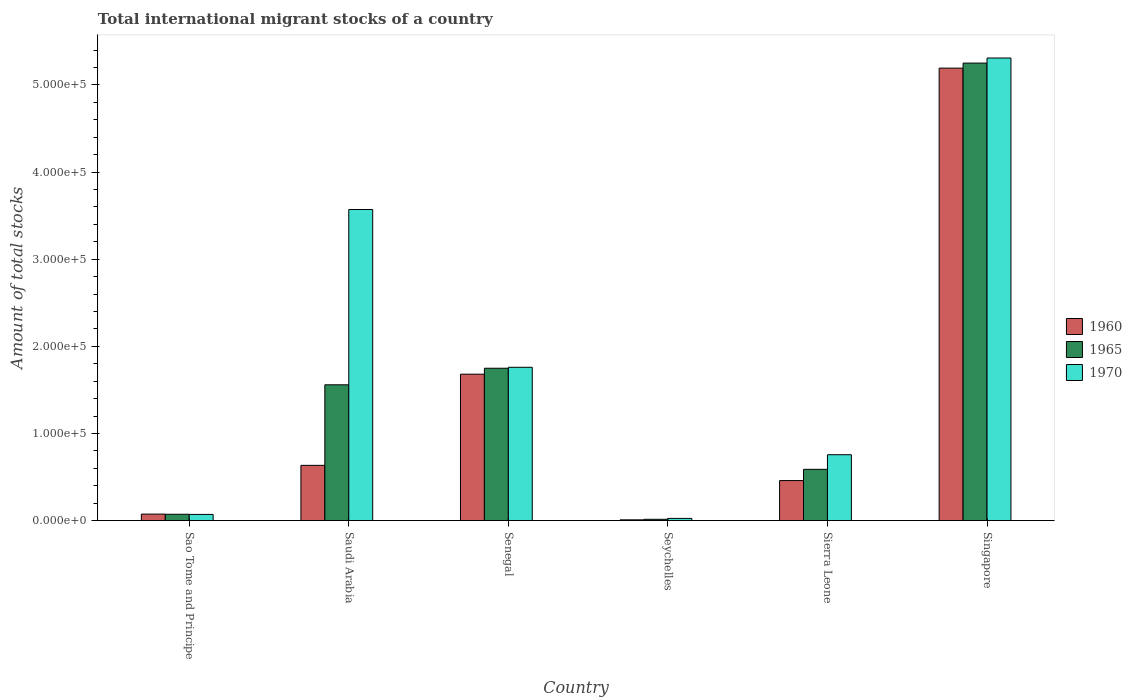How many groups of bars are there?
Your answer should be very brief. 6. Are the number of bars per tick equal to the number of legend labels?
Provide a succinct answer. Yes. What is the label of the 5th group of bars from the left?
Give a very brief answer. Sierra Leone. What is the amount of total stocks in in 1960 in Sierra Leone?
Offer a very short reply. 4.59e+04. Across all countries, what is the maximum amount of total stocks in in 1960?
Your response must be concise. 5.19e+05. Across all countries, what is the minimum amount of total stocks in in 1970?
Offer a terse response. 2506. In which country was the amount of total stocks in in 1965 maximum?
Ensure brevity in your answer.  Singapore. In which country was the amount of total stocks in in 1960 minimum?
Offer a terse response. Seychelles. What is the total amount of total stocks in in 1960 in the graph?
Offer a very short reply. 8.05e+05. What is the difference between the amount of total stocks in in 1965 in Senegal and that in Singapore?
Keep it short and to the point. -3.50e+05. What is the difference between the amount of total stocks in in 1970 in Sao Tome and Principe and the amount of total stocks in in 1960 in Senegal?
Provide a succinct answer. -1.61e+05. What is the average amount of total stocks in in 1960 per country?
Your answer should be very brief. 1.34e+05. What is the difference between the amount of total stocks in of/in 1965 and amount of total stocks in of/in 1970 in Sierra Leone?
Your answer should be very brief. -1.68e+04. In how many countries, is the amount of total stocks in in 1965 greater than 300000?
Make the answer very short. 1. What is the ratio of the amount of total stocks in in 1970 in Saudi Arabia to that in Senegal?
Your answer should be compact. 2.03. Is the amount of total stocks in in 1960 in Sao Tome and Principe less than that in Singapore?
Make the answer very short. Yes. Is the difference between the amount of total stocks in in 1965 in Senegal and Seychelles greater than the difference between the amount of total stocks in in 1970 in Senegal and Seychelles?
Provide a short and direct response. No. What is the difference between the highest and the second highest amount of total stocks in in 1965?
Your response must be concise. 1.90e+04. What is the difference between the highest and the lowest amount of total stocks in in 1960?
Provide a short and direct response. 5.18e+05. In how many countries, is the amount of total stocks in in 1960 greater than the average amount of total stocks in in 1960 taken over all countries?
Make the answer very short. 2. What does the 2nd bar from the left in Seychelles represents?
Give a very brief answer. 1965. What does the 1st bar from the right in Seychelles represents?
Offer a terse response. 1970. Is it the case that in every country, the sum of the amount of total stocks in in 1965 and amount of total stocks in in 1960 is greater than the amount of total stocks in in 1970?
Your answer should be compact. No. Are the values on the major ticks of Y-axis written in scientific E-notation?
Provide a short and direct response. Yes. Does the graph contain grids?
Your answer should be compact. No. What is the title of the graph?
Provide a short and direct response. Total international migrant stocks of a country. Does "1960" appear as one of the legend labels in the graph?
Provide a succinct answer. Yes. What is the label or title of the X-axis?
Your answer should be compact. Country. What is the label or title of the Y-axis?
Ensure brevity in your answer.  Amount of total stocks. What is the Amount of total stocks in 1960 in Sao Tome and Principe?
Provide a short and direct response. 7436. What is the Amount of total stocks in 1965 in Sao Tome and Principe?
Offer a very short reply. 7253. What is the Amount of total stocks of 1970 in Sao Tome and Principe?
Make the answer very short. 7074. What is the Amount of total stocks in 1960 in Saudi Arabia?
Your answer should be compact. 6.34e+04. What is the Amount of total stocks of 1965 in Saudi Arabia?
Offer a terse response. 1.56e+05. What is the Amount of total stocks of 1970 in Saudi Arabia?
Keep it short and to the point. 3.57e+05. What is the Amount of total stocks in 1960 in Senegal?
Provide a short and direct response. 1.68e+05. What is the Amount of total stocks in 1965 in Senegal?
Your answer should be compact. 1.75e+05. What is the Amount of total stocks in 1970 in Senegal?
Keep it short and to the point. 1.76e+05. What is the Amount of total stocks in 1960 in Seychelles?
Offer a terse response. 845. What is the Amount of total stocks in 1965 in Seychelles?
Provide a short and direct response. 1455. What is the Amount of total stocks of 1970 in Seychelles?
Offer a very short reply. 2506. What is the Amount of total stocks of 1960 in Sierra Leone?
Give a very brief answer. 4.59e+04. What is the Amount of total stocks in 1965 in Sierra Leone?
Your answer should be compact. 5.88e+04. What is the Amount of total stocks of 1970 in Sierra Leone?
Your answer should be very brief. 7.56e+04. What is the Amount of total stocks in 1960 in Singapore?
Ensure brevity in your answer.  5.19e+05. What is the Amount of total stocks in 1965 in Singapore?
Keep it short and to the point. 5.25e+05. What is the Amount of total stocks in 1970 in Singapore?
Give a very brief answer. 5.31e+05. Across all countries, what is the maximum Amount of total stocks in 1960?
Keep it short and to the point. 5.19e+05. Across all countries, what is the maximum Amount of total stocks in 1965?
Offer a very short reply. 5.25e+05. Across all countries, what is the maximum Amount of total stocks of 1970?
Make the answer very short. 5.31e+05. Across all countries, what is the minimum Amount of total stocks of 1960?
Offer a terse response. 845. Across all countries, what is the minimum Amount of total stocks in 1965?
Your answer should be very brief. 1455. Across all countries, what is the minimum Amount of total stocks of 1970?
Ensure brevity in your answer.  2506. What is the total Amount of total stocks of 1960 in the graph?
Offer a terse response. 8.05e+05. What is the total Amount of total stocks in 1965 in the graph?
Offer a terse response. 9.23e+05. What is the total Amount of total stocks in 1970 in the graph?
Your answer should be very brief. 1.15e+06. What is the difference between the Amount of total stocks in 1960 in Sao Tome and Principe and that in Saudi Arabia?
Your answer should be very brief. -5.60e+04. What is the difference between the Amount of total stocks of 1965 in Sao Tome and Principe and that in Saudi Arabia?
Your answer should be compact. -1.49e+05. What is the difference between the Amount of total stocks of 1970 in Sao Tome and Principe and that in Saudi Arabia?
Keep it short and to the point. -3.50e+05. What is the difference between the Amount of total stocks in 1960 in Sao Tome and Principe and that in Senegal?
Your answer should be compact. -1.61e+05. What is the difference between the Amount of total stocks of 1965 in Sao Tome and Principe and that in Senegal?
Your answer should be compact. -1.68e+05. What is the difference between the Amount of total stocks of 1970 in Sao Tome and Principe and that in Senegal?
Ensure brevity in your answer.  -1.69e+05. What is the difference between the Amount of total stocks of 1960 in Sao Tome and Principe and that in Seychelles?
Keep it short and to the point. 6591. What is the difference between the Amount of total stocks of 1965 in Sao Tome and Principe and that in Seychelles?
Ensure brevity in your answer.  5798. What is the difference between the Amount of total stocks of 1970 in Sao Tome and Principe and that in Seychelles?
Offer a terse response. 4568. What is the difference between the Amount of total stocks in 1960 in Sao Tome and Principe and that in Sierra Leone?
Provide a short and direct response. -3.85e+04. What is the difference between the Amount of total stocks of 1965 in Sao Tome and Principe and that in Sierra Leone?
Provide a succinct answer. -5.16e+04. What is the difference between the Amount of total stocks in 1970 in Sao Tome and Principe and that in Sierra Leone?
Your answer should be compact. -6.85e+04. What is the difference between the Amount of total stocks in 1960 in Sao Tome and Principe and that in Singapore?
Your response must be concise. -5.12e+05. What is the difference between the Amount of total stocks of 1965 in Sao Tome and Principe and that in Singapore?
Your answer should be compact. -5.18e+05. What is the difference between the Amount of total stocks in 1970 in Sao Tome and Principe and that in Singapore?
Ensure brevity in your answer.  -5.24e+05. What is the difference between the Amount of total stocks of 1960 in Saudi Arabia and that in Senegal?
Give a very brief answer. -1.05e+05. What is the difference between the Amount of total stocks in 1965 in Saudi Arabia and that in Senegal?
Provide a short and direct response. -1.90e+04. What is the difference between the Amount of total stocks of 1970 in Saudi Arabia and that in Senegal?
Offer a very short reply. 1.81e+05. What is the difference between the Amount of total stocks in 1960 in Saudi Arabia and that in Seychelles?
Make the answer very short. 6.25e+04. What is the difference between the Amount of total stocks in 1965 in Saudi Arabia and that in Seychelles?
Your response must be concise. 1.54e+05. What is the difference between the Amount of total stocks in 1970 in Saudi Arabia and that in Seychelles?
Make the answer very short. 3.54e+05. What is the difference between the Amount of total stocks in 1960 in Saudi Arabia and that in Sierra Leone?
Provide a succinct answer. 1.75e+04. What is the difference between the Amount of total stocks in 1965 in Saudi Arabia and that in Sierra Leone?
Your answer should be compact. 9.70e+04. What is the difference between the Amount of total stocks in 1970 in Saudi Arabia and that in Sierra Leone?
Your answer should be compact. 2.81e+05. What is the difference between the Amount of total stocks in 1960 in Saudi Arabia and that in Singapore?
Give a very brief answer. -4.56e+05. What is the difference between the Amount of total stocks of 1965 in Saudi Arabia and that in Singapore?
Your response must be concise. -3.69e+05. What is the difference between the Amount of total stocks of 1970 in Saudi Arabia and that in Singapore?
Your answer should be compact. -1.74e+05. What is the difference between the Amount of total stocks in 1960 in Senegal and that in Seychelles?
Your answer should be compact. 1.67e+05. What is the difference between the Amount of total stocks in 1965 in Senegal and that in Seychelles?
Make the answer very short. 1.73e+05. What is the difference between the Amount of total stocks in 1970 in Senegal and that in Seychelles?
Your answer should be compact. 1.73e+05. What is the difference between the Amount of total stocks in 1960 in Senegal and that in Sierra Leone?
Your response must be concise. 1.22e+05. What is the difference between the Amount of total stocks of 1965 in Senegal and that in Sierra Leone?
Your response must be concise. 1.16e+05. What is the difference between the Amount of total stocks of 1970 in Senegal and that in Sierra Leone?
Keep it short and to the point. 1.00e+05. What is the difference between the Amount of total stocks in 1960 in Senegal and that in Singapore?
Give a very brief answer. -3.51e+05. What is the difference between the Amount of total stocks in 1965 in Senegal and that in Singapore?
Your response must be concise. -3.50e+05. What is the difference between the Amount of total stocks in 1970 in Senegal and that in Singapore?
Make the answer very short. -3.55e+05. What is the difference between the Amount of total stocks of 1960 in Seychelles and that in Sierra Leone?
Offer a very short reply. -4.51e+04. What is the difference between the Amount of total stocks in 1965 in Seychelles and that in Sierra Leone?
Offer a terse response. -5.74e+04. What is the difference between the Amount of total stocks in 1970 in Seychelles and that in Sierra Leone?
Keep it short and to the point. -7.31e+04. What is the difference between the Amount of total stocks of 1960 in Seychelles and that in Singapore?
Offer a very short reply. -5.18e+05. What is the difference between the Amount of total stocks of 1965 in Seychelles and that in Singapore?
Offer a very short reply. -5.24e+05. What is the difference between the Amount of total stocks in 1970 in Seychelles and that in Singapore?
Your response must be concise. -5.28e+05. What is the difference between the Amount of total stocks of 1960 in Sierra Leone and that in Singapore?
Keep it short and to the point. -4.73e+05. What is the difference between the Amount of total stocks in 1965 in Sierra Leone and that in Singapore?
Offer a very short reply. -4.66e+05. What is the difference between the Amount of total stocks of 1970 in Sierra Leone and that in Singapore?
Make the answer very short. -4.55e+05. What is the difference between the Amount of total stocks of 1960 in Sao Tome and Principe and the Amount of total stocks of 1965 in Saudi Arabia?
Make the answer very short. -1.48e+05. What is the difference between the Amount of total stocks in 1960 in Sao Tome and Principe and the Amount of total stocks in 1970 in Saudi Arabia?
Ensure brevity in your answer.  -3.50e+05. What is the difference between the Amount of total stocks of 1965 in Sao Tome and Principe and the Amount of total stocks of 1970 in Saudi Arabia?
Give a very brief answer. -3.50e+05. What is the difference between the Amount of total stocks of 1960 in Sao Tome and Principe and the Amount of total stocks of 1965 in Senegal?
Your answer should be very brief. -1.67e+05. What is the difference between the Amount of total stocks in 1960 in Sao Tome and Principe and the Amount of total stocks in 1970 in Senegal?
Make the answer very short. -1.68e+05. What is the difference between the Amount of total stocks of 1965 in Sao Tome and Principe and the Amount of total stocks of 1970 in Senegal?
Make the answer very short. -1.69e+05. What is the difference between the Amount of total stocks of 1960 in Sao Tome and Principe and the Amount of total stocks of 1965 in Seychelles?
Give a very brief answer. 5981. What is the difference between the Amount of total stocks of 1960 in Sao Tome and Principe and the Amount of total stocks of 1970 in Seychelles?
Provide a short and direct response. 4930. What is the difference between the Amount of total stocks of 1965 in Sao Tome and Principe and the Amount of total stocks of 1970 in Seychelles?
Offer a terse response. 4747. What is the difference between the Amount of total stocks of 1960 in Sao Tome and Principe and the Amount of total stocks of 1965 in Sierra Leone?
Provide a succinct answer. -5.14e+04. What is the difference between the Amount of total stocks of 1960 in Sao Tome and Principe and the Amount of total stocks of 1970 in Sierra Leone?
Offer a very short reply. -6.81e+04. What is the difference between the Amount of total stocks in 1965 in Sao Tome and Principe and the Amount of total stocks in 1970 in Sierra Leone?
Your answer should be compact. -6.83e+04. What is the difference between the Amount of total stocks of 1960 in Sao Tome and Principe and the Amount of total stocks of 1965 in Singapore?
Your response must be concise. -5.18e+05. What is the difference between the Amount of total stocks of 1960 in Sao Tome and Principe and the Amount of total stocks of 1970 in Singapore?
Your answer should be compact. -5.23e+05. What is the difference between the Amount of total stocks of 1965 in Sao Tome and Principe and the Amount of total stocks of 1970 in Singapore?
Your answer should be compact. -5.24e+05. What is the difference between the Amount of total stocks of 1960 in Saudi Arabia and the Amount of total stocks of 1965 in Senegal?
Your answer should be compact. -1.11e+05. What is the difference between the Amount of total stocks of 1960 in Saudi Arabia and the Amount of total stocks of 1970 in Senegal?
Give a very brief answer. -1.13e+05. What is the difference between the Amount of total stocks in 1965 in Saudi Arabia and the Amount of total stocks in 1970 in Senegal?
Make the answer very short. -2.01e+04. What is the difference between the Amount of total stocks of 1960 in Saudi Arabia and the Amount of total stocks of 1965 in Seychelles?
Ensure brevity in your answer.  6.19e+04. What is the difference between the Amount of total stocks of 1960 in Saudi Arabia and the Amount of total stocks of 1970 in Seychelles?
Ensure brevity in your answer.  6.09e+04. What is the difference between the Amount of total stocks in 1965 in Saudi Arabia and the Amount of total stocks in 1970 in Seychelles?
Give a very brief answer. 1.53e+05. What is the difference between the Amount of total stocks in 1960 in Saudi Arabia and the Amount of total stocks in 1965 in Sierra Leone?
Ensure brevity in your answer.  4580. What is the difference between the Amount of total stocks in 1960 in Saudi Arabia and the Amount of total stocks in 1970 in Sierra Leone?
Ensure brevity in your answer.  -1.22e+04. What is the difference between the Amount of total stocks in 1965 in Saudi Arabia and the Amount of total stocks in 1970 in Sierra Leone?
Provide a succinct answer. 8.02e+04. What is the difference between the Amount of total stocks in 1960 in Saudi Arabia and the Amount of total stocks in 1965 in Singapore?
Your answer should be very brief. -4.62e+05. What is the difference between the Amount of total stocks in 1960 in Saudi Arabia and the Amount of total stocks in 1970 in Singapore?
Give a very brief answer. -4.67e+05. What is the difference between the Amount of total stocks of 1965 in Saudi Arabia and the Amount of total stocks of 1970 in Singapore?
Your answer should be compact. -3.75e+05. What is the difference between the Amount of total stocks of 1960 in Senegal and the Amount of total stocks of 1965 in Seychelles?
Give a very brief answer. 1.67e+05. What is the difference between the Amount of total stocks in 1960 in Senegal and the Amount of total stocks in 1970 in Seychelles?
Provide a succinct answer. 1.66e+05. What is the difference between the Amount of total stocks in 1965 in Senegal and the Amount of total stocks in 1970 in Seychelles?
Ensure brevity in your answer.  1.72e+05. What is the difference between the Amount of total stocks in 1960 in Senegal and the Amount of total stocks in 1965 in Sierra Leone?
Your response must be concise. 1.09e+05. What is the difference between the Amount of total stocks of 1960 in Senegal and the Amount of total stocks of 1970 in Sierra Leone?
Make the answer very short. 9.24e+04. What is the difference between the Amount of total stocks of 1965 in Senegal and the Amount of total stocks of 1970 in Sierra Leone?
Ensure brevity in your answer.  9.92e+04. What is the difference between the Amount of total stocks of 1960 in Senegal and the Amount of total stocks of 1965 in Singapore?
Keep it short and to the point. -3.57e+05. What is the difference between the Amount of total stocks of 1960 in Senegal and the Amount of total stocks of 1970 in Singapore?
Your answer should be compact. -3.63e+05. What is the difference between the Amount of total stocks in 1965 in Senegal and the Amount of total stocks in 1970 in Singapore?
Your response must be concise. -3.56e+05. What is the difference between the Amount of total stocks in 1960 in Seychelles and the Amount of total stocks in 1965 in Sierra Leone?
Your response must be concise. -5.80e+04. What is the difference between the Amount of total stocks of 1960 in Seychelles and the Amount of total stocks of 1970 in Sierra Leone?
Give a very brief answer. -7.47e+04. What is the difference between the Amount of total stocks of 1965 in Seychelles and the Amount of total stocks of 1970 in Sierra Leone?
Your response must be concise. -7.41e+04. What is the difference between the Amount of total stocks of 1960 in Seychelles and the Amount of total stocks of 1965 in Singapore?
Your answer should be compact. -5.24e+05. What is the difference between the Amount of total stocks of 1960 in Seychelles and the Amount of total stocks of 1970 in Singapore?
Your answer should be compact. -5.30e+05. What is the difference between the Amount of total stocks in 1965 in Seychelles and the Amount of total stocks in 1970 in Singapore?
Your answer should be very brief. -5.29e+05. What is the difference between the Amount of total stocks in 1960 in Sierra Leone and the Amount of total stocks in 1965 in Singapore?
Your answer should be very brief. -4.79e+05. What is the difference between the Amount of total stocks in 1960 in Sierra Leone and the Amount of total stocks in 1970 in Singapore?
Offer a very short reply. -4.85e+05. What is the difference between the Amount of total stocks of 1965 in Sierra Leone and the Amount of total stocks of 1970 in Singapore?
Ensure brevity in your answer.  -4.72e+05. What is the average Amount of total stocks of 1960 per country?
Your response must be concise. 1.34e+05. What is the average Amount of total stocks of 1965 per country?
Your answer should be very brief. 1.54e+05. What is the average Amount of total stocks of 1970 per country?
Your answer should be compact. 1.91e+05. What is the difference between the Amount of total stocks in 1960 and Amount of total stocks in 1965 in Sao Tome and Principe?
Your response must be concise. 183. What is the difference between the Amount of total stocks in 1960 and Amount of total stocks in 1970 in Sao Tome and Principe?
Your answer should be compact. 362. What is the difference between the Amount of total stocks of 1965 and Amount of total stocks of 1970 in Sao Tome and Principe?
Offer a terse response. 179. What is the difference between the Amount of total stocks of 1960 and Amount of total stocks of 1965 in Saudi Arabia?
Make the answer very short. -9.24e+04. What is the difference between the Amount of total stocks of 1960 and Amount of total stocks of 1970 in Saudi Arabia?
Give a very brief answer. -2.94e+05. What is the difference between the Amount of total stocks of 1965 and Amount of total stocks of 1970 in Saudi Arabia?
Provide a short and direct response. -2.01e+05. What is the difference between the Amount of total stocks of 1960 and Amount of total stocks of 1965 in Senegal?
Your answer should be compact. -6804. What is the difference between the Amount of total stocks in 1960 and Amount of total stocks in 1970 in Senegal?
Provide a short and direct response. -7897. What is the difference between the Amount of total stocks in 1965 and Amount of total stocks in 1970 in Senegal?
Your answer should be compact. -1093. What is the difference between the Amount of total stocks in 1960 and Amount of total stocks in 1965 in Seychelles?
Give a very brief answer. -610. What is the difference between the Amount of total stocks in 1960 and Amount of total stocks in 1970 in Seychelles?
Your response must be concise. -1661. What is the difference between the Amount of total stocks in 1965 and Amount of total stocks in 1970 in Seychelles?
Your response must be concise. -1051. What is the difference between the Amount of total stocks of 1960 and Amount of total stocks of 1965 in Sierra Leone?
Your answer should be compact. -1.29e+04. What is the difference between the Amount of total stocks of 1960 and Amount of total stocks of 1970 in Sierra Leone?
Provide a succinct answer. -2.97e+04. What is the difference between the Amount of total stocks in 1965 and Amount of total stocks in 1970 in Sierra Leone?
Your answer should be compact. -1.68e+04. What is the difference between the Amount of total stocks of 1960 and Amount of total stocks of 1965 in Singapore?
Your answer should be compact. -5801. What is the difference between the Amount of total stocks of 1960 and Amount of total stocks of 1970 in Singapore?
Keep it short and to the point. -1.16e+04. What is the difference between the Amount of total stocks in 1965 and Amount of total stocks in 1970 in Singapore?
Make the answer very short. -5826. What is the ratio of the Amount of total stocks in 1960 in Sao Tome and Principe to that in Saudi Arabia?
Make the answer very short. 0.12. What is the ratio of the Amount of total stocks of 1965 in Sao Tome and Principe to that in Saudi Arabia?
Provide a short and direct response. 0.05. What is the ratio of the Amount of total stocks of 1970 in Sao Tome and Principe to that in Saudi Arabia?
Provide a succinct answer. 0.02. What is the ratio of the Amount of total stocks in 1960 in Sao Tome and Principe to that in Senegal?
Your response must be concise. 0.04. What is the ratio of the Amount of total stocks of 1965 in Sao Tome and Principe to that in Senegal?
Give a very brief answer. 0.04. What is the ratio of the Amount of total stocks in 1970 in Sao Tome and Principe to that in Senegal?
Offer a terse response. 0.04. What is the ratio of the Amount of total stocks in 1960 in Sao Tome and Principe to that in Seychelles?
Your answer should be very brief. 8.8. What is the ratio of the Amount of total stocks of 1965 in Sao Tome and Principe to that in Seychelles?
Your response must be concise. 4.98. What is the ratio of the Amount of total stocks in 1970 in Sao Tome and Principe to that in Seychelles?
Offer a very short reply. 2.82. What is the ratio of the Amount of total stocks of 1960 in Sao Tome and Principe to that in Sierra Leone?
Make the answer very short. 0.16. What is the ratio of the Amount of total stocks in 1965 in Sao Tome and Principe to that in Sierra Leone?
Offer a very short reply. 0.12. What is the ratio of the Amount of total stocks in 1970 in Sao Tome and Principe to that in Sierra Leone?
Keep it short and to the point. 0.09. What is the ratio of the Amount of total stocks in 1960 in Sao Tome and Principe to that in Singapore?
Offer a very short reply. 0.01. What is the ratio of the Amount of total stocks in 1965 in Sao Tome and Principe to that in Singapore?
Your answer should be very brief. 0.01. What is the ratio of the Amount of total stocks in 1970 in Sao Tome and Principe to that in Singapore?
Give a very brief answer. 0.01. What is the ratio of the Amount of total stocks of 1960 in Saudi Arabia to that in Senegal?
Offer a very short reply. 0.38. What is the ratio of the Amount of total stocks in 1965 in Saudi Arabia to that in Senegal?
Offer a terse response. 0.89. What is the ratio of the Amount of total stocks in 1970 in Saudi Arabia to that in Senegal?
Give a very brief answer. 2.03. What is the ratio of the Amount of total stocks of 1960 in Saudi Arabia to that in Seychelles?
Give a very brief answer. 75.02. What is the ratio of the Amount of total stocks of 1965 in Saudi Arabia to that in Seychelles?
Make the answer very short. 107.09. What is the ratio of the Amount of total stocks of 1970 in Saudi Arabia to that in Seychelles?
Make the answer very short. 142.46. What is the ratio of the Amount of total stocks of 1960 in Saudi Arabia to that in Sierra Leone?
Your answer should be compact. 1.38. What is the ratio of the Amount of total stocks of 1965 in Saudi Arabia to that in Sierra Leone?
Keep it short and to the point. 2.65. What is the ratio of the Amount of total stocks of 1970 in Saudi Arabia to that in Sierra Leone?
Your answer should be compact. 4.72. What is the ratio of the Amount of total stocks of 1960 in Saudi Arabia to that in Singapore?
Give a very brief answer. 0.12. What is the ratio of the Amount of total stocks of 1965 in Saudi Arabia to that in Singapore?
Your answer should be compact. 0.3. What is the ratio of the Amount of total stocks of 1970 in Saudi Arabia to that in Singapore?
Give a very brief answer. 0.67. What is the ratio of the Amount of total stocks in 1960 in Senegal to that in Seychelles?
Your response must be concise. 198.84. What is the ratio of the Amount of total stocks of 1965 in Senegal to that in Seychelles?
Provide a succinct answer. 120.15. What is the ratio of the Amount of total stocks in 1970 in Senegal to that in Seychelles?
Your response must be concise. 70.2. What is the ratio of the Amount of total stocks of 1960 in Senegal to that in Sierra Leone?
Offer a terse response. 3.66. What is the ratio of the Amount of total stocks of 1965 in Senegal to that in Sierra Leone?
Make the answer very short. 2.97. What is the ratio of the Amount of total stocks of 1970 in Senegal to that in Sierra Leone?
Provide a succinct answer. 2.33. What is the ratio of the Amount of total stocks in 1960 in Senegal to that in Singapore?
Ensure brevity in your answer.  0.32. What is the ratio of the Amount of total stocks of 1965 in Senegal to that in Singapore?
Provide a short and direct response. 0.33. What is the ratio of the Amount of total stocks of 1970 in Senegal to that in Singapore?
Ensure brevity in your answer.  0.33. What is the ratio of the Amount of total stocks of 1960 in Seychelles to that in Sierra Leone?
Ensure brevity in your answer.  0.02. What is the ratio of the Amount of total stocks of 1965 in Seychelles to that in Sierra Leone?
Provide a succinct answer. 0.02. What is the ratio of the Amount of total stocks in 1970 in Seychelles to that in Sierra Leone?
Provide a short and direct response. 0.03. What is the ratio of the Amount of total stocks in 1960 in Seychelles to that in Singapore?
Ensure brevity in your answer.  0. What is the ratio of the Amount of total stocks of 1965 in Seychelles to that in Singapore?
Provide a succinct answer. 0. What is the ratio of the Amount of total stocks of 1970 in Seychelles to that in Singapore?
Your answer should be very brief. 0. What is the ratio of the Amount of total stocks of 1960 in Sierra Leone to that in Singapore?
Your response must be concise. 0.09. What is the ratio of the Amount of total stocks in 1965 in Sierra Leone to that in Singapore?
Ensure brevity in your answer.  0.11. What is the ratio of the Amount of total stocks in 1970 in Sierra Leone to that in Singapore?
Provide a succinct answer. 0.14. What is the difference between the highest and the second highest Amount of total stocks in 1960?
Give a very brief answer. 3.51e+05. What is the difference between the highest and the second highest Amount of total stocks in 1965?
Provide a succinct answer. 3.50e+05. What is the difference between the highest and the second highest Amount of total stocks of 1970?
Offer a terse response. 1.74e+05. What is the difference between the highest and the lowest Amount of total stocks of 1960?
Keep it short and to the point. 5.18e+05. What is the difference between the highest and the lowest Amount of total stocks of 1965?
Make the answer very short. 5.24e+05. What is the difference between the highest and the lowest Amount of total stocks of 1970?
Give a very brief answer. 5.28e+05. 